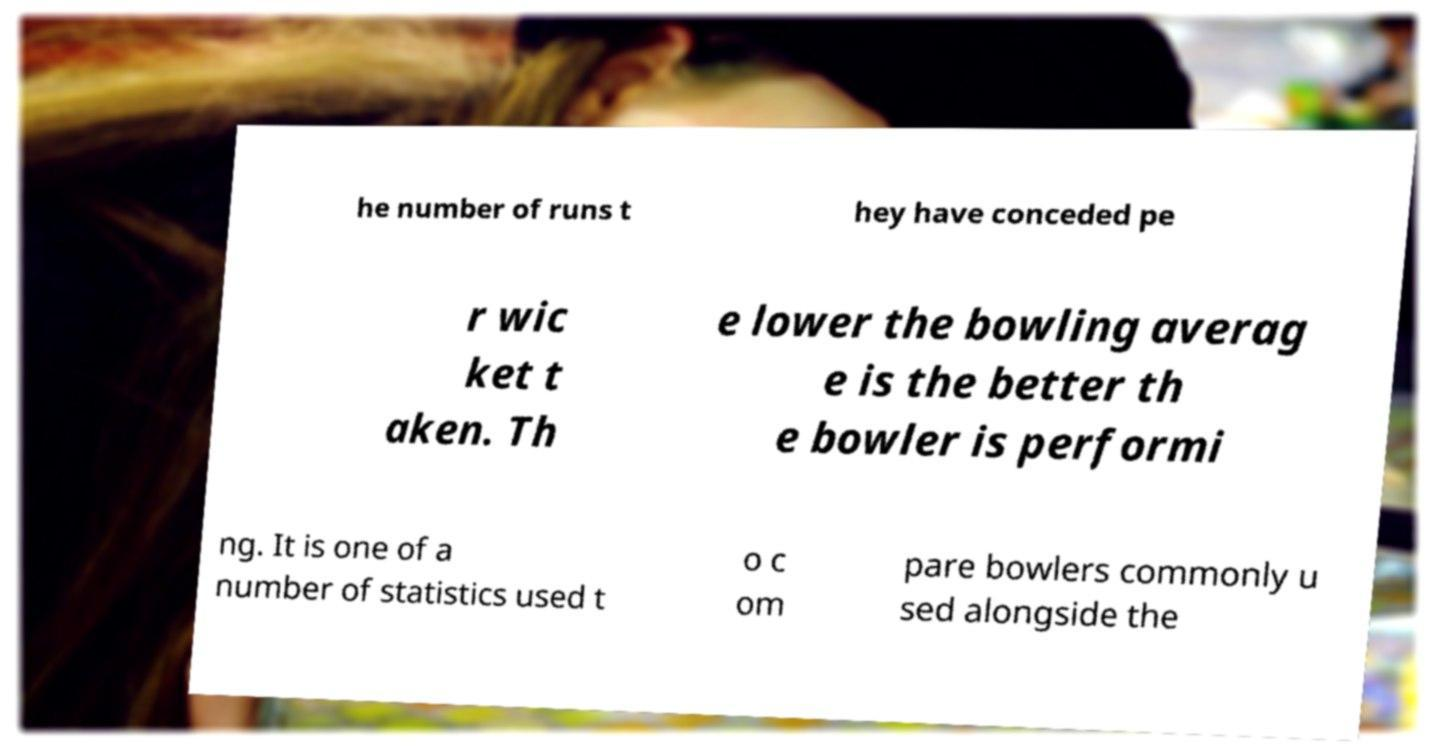Could you assist in decoding the text presented in this image and type it out clearly? he number of runs t hey have conceded pe r wic ket t aken. Th e lower the bowling averag e is the better th e bowler is performi ng. It is one of a number of statistics used t o c om pare bowlers commonly u sed alongside the 